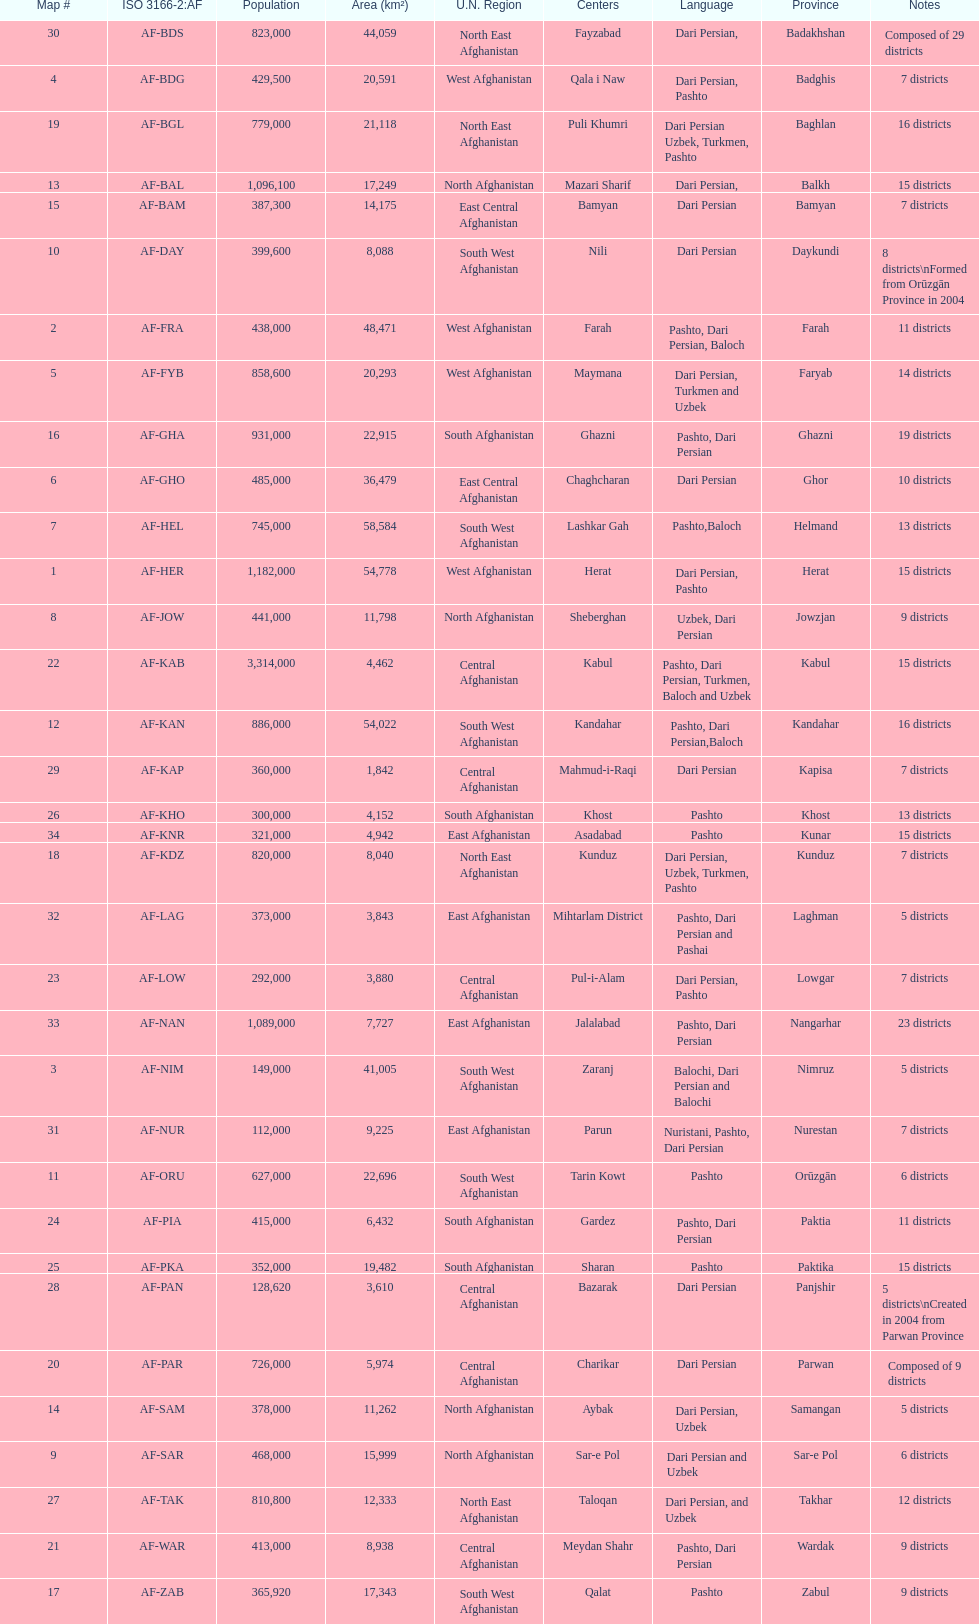Help me parse the entirety of this table. {'header': ['Map #', 'ISO 3166-2:AF', 'Population', 'Area (km²)', 'U.N. Region', 'Centers', 'Language', 'Province', 'Notes'], 'rows': [['30', 'AF-BDS', '823,000', '44,059', 'North East Afghanistan', 'Fayzabad', 'Dari Persian,', 'Badakhshan', 'Composed of 29 districts'], ['4', 'AF-BDG', '429,500', '20,591', 'West Afghanistan', 'Qala i Naw', 'Dari Persian, Pashto', 'Badghis', '7 districts'], ['19', 'AF-BGL', '779,000', '21,118', 'North East Afghanistan', 'Puli Khumri', 'Dari Persian Uzbek, Turkmen, Pashto', 'Baghlan', '16 districts'], ['13', 'AF-BAL', '1,096,100', '17,249', 'North Afghanistan', 'Mazari Sharif', 'Dari Persian,', 'Balkh', '15 districts'], ['15', 'AF-BAM', '387,300', '14,175', 'East Central Afghanistan', 'Bamyan', 'Dari Persian', 'Bamyan', '7 districts'], ['10', 'AF-DAY', '399,600', '8,088', 'South West Afghanistan', 'Nili', 'Dari Persian', 'Daykundi', '8 districts\\nFormed from Orūzgān Province in 2004'], ['2', 'AF-FRA', '438,000', '48,471', 'West Afghanistan', 'Farah', 'Pashto, Dari Persian, Baloch', 'Farah', '11 districts'], ['5', 'AF-FYB', '858,600', '20,293', 'West Afghanistan', 'Maymana', 'Dari Persian, Turkmen and Uzbek', 'Faryab', '14 districts'], ['16', 'AF-GHA', '931,000', '22,915', 'South Afghanistan', 'Ghazni', 'Pashto, Dari Persian', 'Ghazni', '19 districts'], ['6', 'AF-GHO', '485,000', '36,479', 'East Central Afghanistan', 'Chaghcharan', 'Dari Persian', 'Ghor', '10 districts'], ['7', 'AF-HEL', '745,000', '58,584', 'South West Afghanistan', 'Lashkar Gah', 'Pashto,Baloch', 'Helmand', '13 districts'], ['1', 'AF-HER', '1,182,000', '54,778', 'West Afghanistan', 'Herat', 'Dari Persian, Pashto', 'Herat', '15 districts'], ['8', 'AF-JOW', '441,000', '11,798', 'North Afghanistan', 'Sheberghan', 'Uzbek, Dari Persian', 'Jowzjan', '9 districts'], ['22', 'AF-KAB', '3,314,000', '4,462', 'Central Afghanistan', 'Kabul', 'Pashto, Dari Persian, Turkmen, Baloch and Uzbek', 'Kabul', '15 districts'], ['12', 'AF-KAN', '886,000', '54,022', 'South West Afghanistan', 'Kandahar', 'Pashto, Dari Persian,Baloch', 'Kandahar', '16 districts'], ['29', 'AF-KAP', '360,000', '1,842', 'Central Afghanistan', 'Mahmud-i-Raqi', 'Dari Persian', 'Kapisa', '7 districts'], ['26', 'AF-KHO', '300,000', '4,152', 'South Afghanistan', 'Khost', 'Pashto', 'Khost', '13 districts'], ['34', 'AF-KNR', '321,000', '4,942', 'East Afghanistan', 'Asadabad', 'Pashto', 'Kunar', '15 districts'], ['18', 'AF-KDZ', '820,000', '8,040', 'North East Afghanistan', 'Kunduz', 'Dari Persian, Uzbek, Turkmen, Pashto', 'Kunduz', '7 districts'], ['32', 'AF-LAG', '373,000', '3,843', 'East Afghanistan', 'Mihtarlam District', 'Pashto, Dari Persian and Pashai', 'Laghman', '5 districts'], ['23', 'AF-LOW', '292,000', '3,880', 'Central Afghanistan', 'Pul-i-Alam', 'Dari Persian, Pashto', 'Lowgar', '7 districts'], ['33', 'AF-NAN', '1,089,000', '7,727', 'East Afghanistan', 'Jalalabad', 'Pashto, Dari Persian', 'Nangarhar', '23 districts'], ['3', 'AF-NIM', '149,000', '41,005', 'South West Afghanistan', 'Zaranj', 'Balochi, Dari Persian and Balochi', 'Nimruz', '5 districts'], ['31', 'AF-NUR', '112,000', '9,225', 'East Afghanistan', 'Parun', 'Nuristani, Pashto, Dari Persian', 'Nurestan', '7 districts'], ['11', 'AF-ORU', '627,000', '22,696', 'South West Afghanistan', 'Tarin Kowt', 'Pashto', 'Orūzgān', '6 districts'], ['24', 'AF-PIA', '415,000', '6,432', 'South Afghanistan', 'Gardez', 'Pashto, Dari Persian', 'Paktia', '11 districts'], ['25', 'AF-PKA', '352,000', '19,482', 'South Afghanistan', 'Sharan', 'Pashto', 'Paktika', '15 districts'], ['28', 'AF-PAN', '128,620', '3,610', 'Central Afghanistan', 'Bazarak', 'Dari Persian', 'Panjshir', '5 districts\\nCreated in 2004 from Parwan Province'], ['20', 'AF-PAR', '726,000', '5,974', 'Central Afghanistan', 'Charikar', 'Dari Persian', 'Parwan', 'Composed of 9 districts'], ['14', 'AF-SAM', '378,000', '11,262', 'North Afghanistan', 'Aybak', 'Dari Persian, Uzbek', 'Samangan', '5 districts'], ['9', 'AF-SAR', '468,000', '15,999', 'North Afghanistan', 'Sar-e Pol', 'Dari Persian and Uzbek', 'Sar-e Pol', '6 districts'], ['27', 'AF-TAK', '810,800', '12,333', 'North East Afghanistan', 'Taloqan', 'Dari Persian, and Uzbek', 'Takhar', '12 districts'], ['21', 'AF-WAR', '413,000', '8,938', 'Central Afghanistan', 'Meydan Shahr', 'Pashto, Dari Persian', 'Wardak', '9 districts'], ['17', 'AF-ZAB', '365,920', '17,343', 'South West Afghanistan', 'Qalat', 'Pashto', 'Zabul', '9 districts']]} What province in afghanistanhas the greatest population? Kabul. 